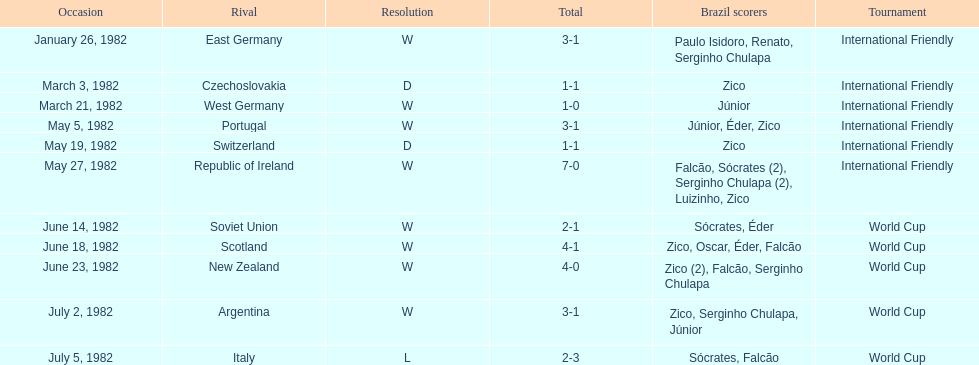How many games did zico end up scoring in during this season? 7. 